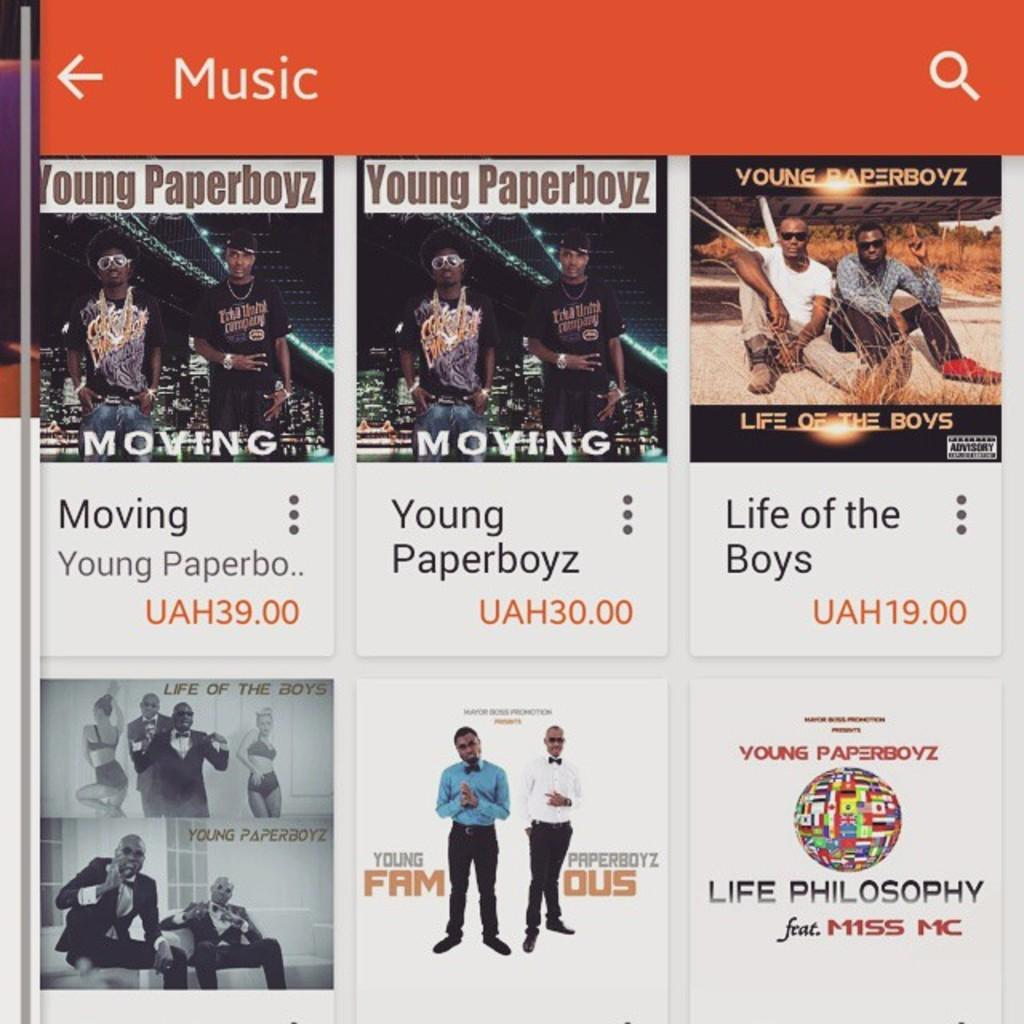What type of page is shown in the image? The image is an application page. What can be found on the application page? There is some information on the page. How many minutes are required to complete the application in the image? The image does not provide information about the time required to complete the application, so it cannot be determined from the image. 